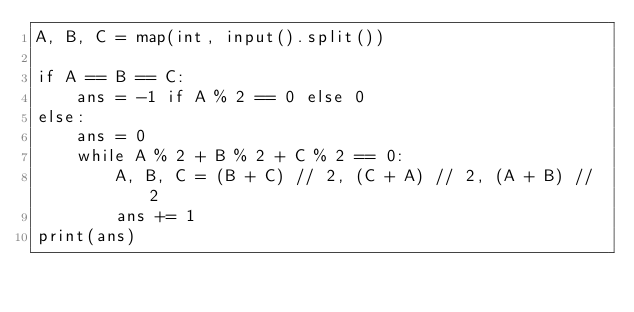<code> <loc_0><loc_0><loc_500><loc_500><_Python_>A, B, C = map(int, input().split())

if A == B == C:
    ans = -1 if A % 2 == 0 else 0
else:
    ans = 0
    while A % 2 + B % 2 + C % 2 == 0:
        A, B, C = (B + C) // 2, (C + A) // 2, (A + B) // 2
        ans += 1
print(ans)
</code> 